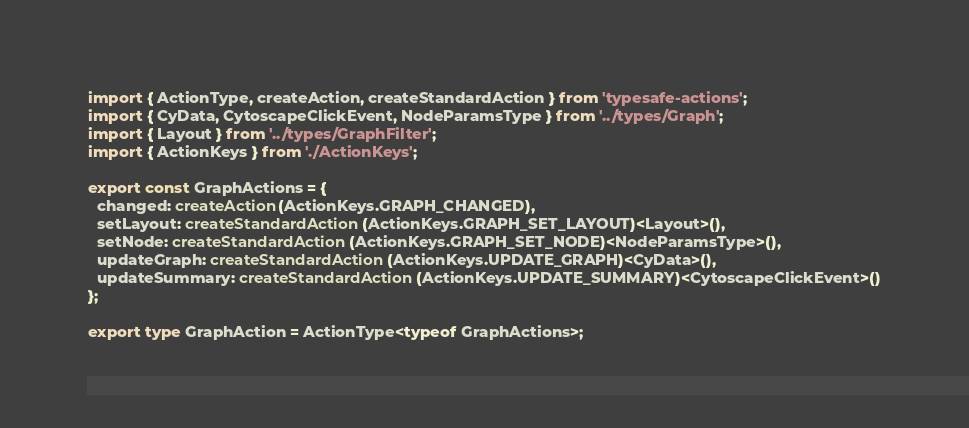Convert code to text. <code><loc_0><loc_0><loc_500><loc_500><_TypeScript_>import { ActionType, createAction, createStandardAction } from 'typesafe-actions';
import { CyData, CytoscapeClickEvent, NodeParamsType } from '../types/Graph';
import { Layout } from '../types/GraphFilter';
import { ActionKeys } from './ActionKeys';

export const GraphActions = {
  changed: createAction(ActionKeys.GRAPH_CHANGED),
  setLayout: createStandardAction(ActionKeys.GRAPH_SET_LAYOUT)<Layout>(),
  setNode: createStandardAction(ActionKeys.GRAPH_SET_NODE)<NodeParamsType>(),
  updateGraph: createStandardAction(ActionKeys.UPDATE_GRAPH)<CyData>(),
  updateSummary: createStandardAction(ActionKeys.UPDATE_SUMMARY)<CytoscapeClickEvent>()
};

export type GraphAction = ActionType<typeof GraphActions>;
</code> 